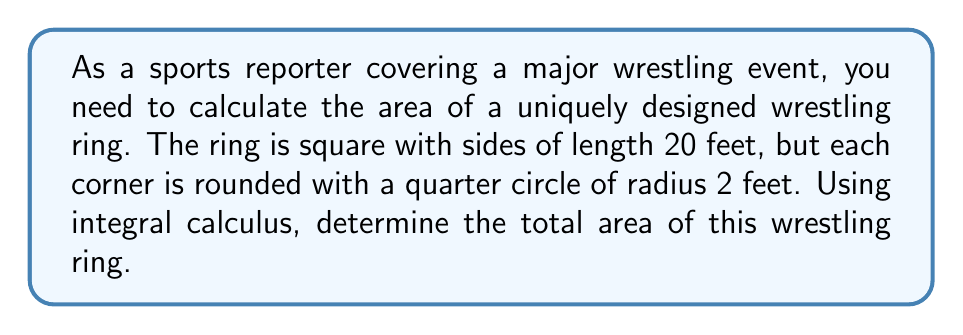Give your solution to this math problem. Let's approach this step-by-step:

1) First, we need to visualize the ring. It's a square with rounded corners:

[asy]
unitsize(10);
path square = (0,0)--(2,0)--(2,2)--(0,2)--cycle;
path arc1 = arc((0,0),0.2,0,90);
path arc2 = arc((2,0),0.2,90,180);
path arc3 = arc((2,2),0.2,180,270);
path arc4 = arc((0,2),0.2,270,360);
draw(square);
draw(arc1);
draw(arc2);
draw(arc3);
draw(arc4);
label("20 ft", (1,-0.1), S);
label("20 ft", (2.1,1), E);
label("2 ft", (0.1,0.1), NE);
[/asy]

2) The total area will be the area of the square minus the area of the four corners plus the area of the four quarter circles.

3) Area of the square: $A_{square} = 20^2 = 400$ sq ft

4) Area of one corner (before rounding):
   $A_{corner} = 2^2 = 4$ sq ft
   Total area of four corners: $4 * 4 = 16$ sq ft

5) Area of a quarter circle:
   $A_{quarter} = \int_0^2 \sqrt{4-x^2} dx$

   To solve this integral:
   Let $x = 2\sin\theta$, then $dx = 2\cos\theta d\theta$
   When $x = 0$, $\theta = 0$
   When $x = 2$, $\theta = \frac{\pi}{2}$

   $\int_0^2 \sqrt{4-x^2} dx = \int_0^{\frac{\pi}{2}} \sqrt{4-4\sin^2\theta} * 2\cos\theta d\theta$
   $= \int_0^{\frac{\pi}{2}} 2\sqrt{\cos^2\theta} * 2\cos\theta d\theta$
   $= 4\int_0^{\frac{\pi}{2}} \cos^2\theta d\theta$
   $= 4 * \frac{\pi}{4} = \pi$ sq ft

6) Total area of four quarter circles: $4\pi$ sq ft

7) Therefore, the total area of the ring is:
   $A_{total} = A_{square} - A_{corners} + A_{quarters}$
   $= 400 - 16 + 4\pi$
   $= 384 + 4\pi$ sq ft
Answer: $384 + 4\pi$ square feet (approximately 396.55 square feet) 